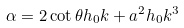Convert formula to latex. <formula><loc_0><loc_0><loc_500><loc_500>\alpha = 2 \cot \theta h _ { 0 } k + a ^ { 2 } h _ { 0 } k ^ { 3 }</formula> 